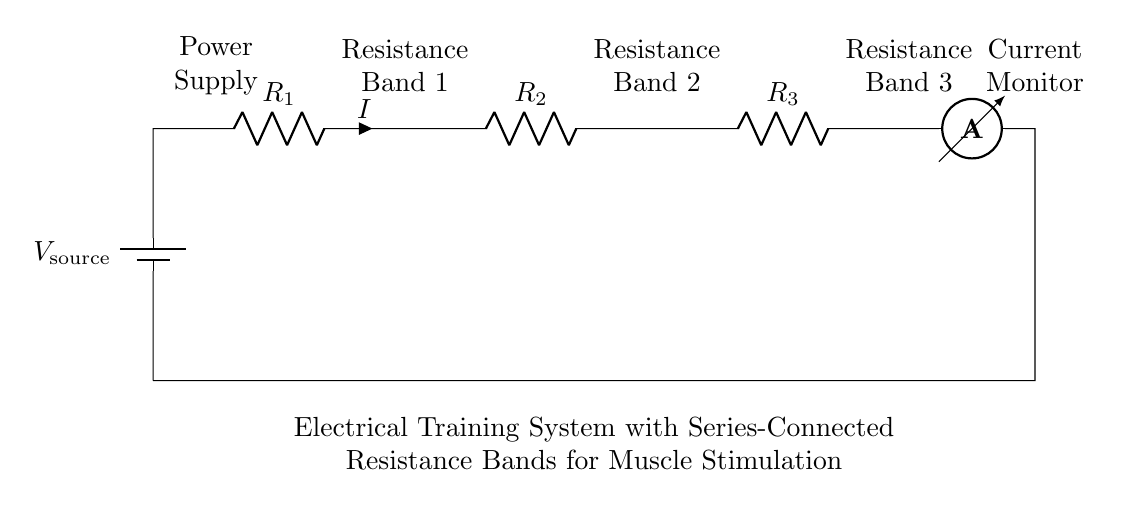What type of current is monitored in this circuit? The circuit features a current monitor, indicating that it measures direct current as it passes through the resistance bands.
Answer: Direct current How many resistance bands are in series? There are three resistance bands connected in series in the arrangement.
Answer: Three What is the total resistance if all bands are equal at 10 Ohms each? The total resistance in a series circuit is the sum of the individual resistances. Therefore, R_total = R_1 + R_2 + R_3 = 10 + 10 + 10 = 30 Ohms.
Answer: 30 Ohms If the source voltage is 12V, what is the current flowing through the circuit? Ohm's law states that current is equal to voltage divided by resistance (I = V/R). Using the total resistance calculated earlier (30 Ohms), the current would be I = 12V / 30 Ohms = 0.4 Amps.
Answer: 0.4 Amps What happens to the current if one resistance band is removed? In a series circuit, removing one resistor increases the total resistance and, consequently, decreases the total current according to Ohm's law.
Answer: Current decreases 